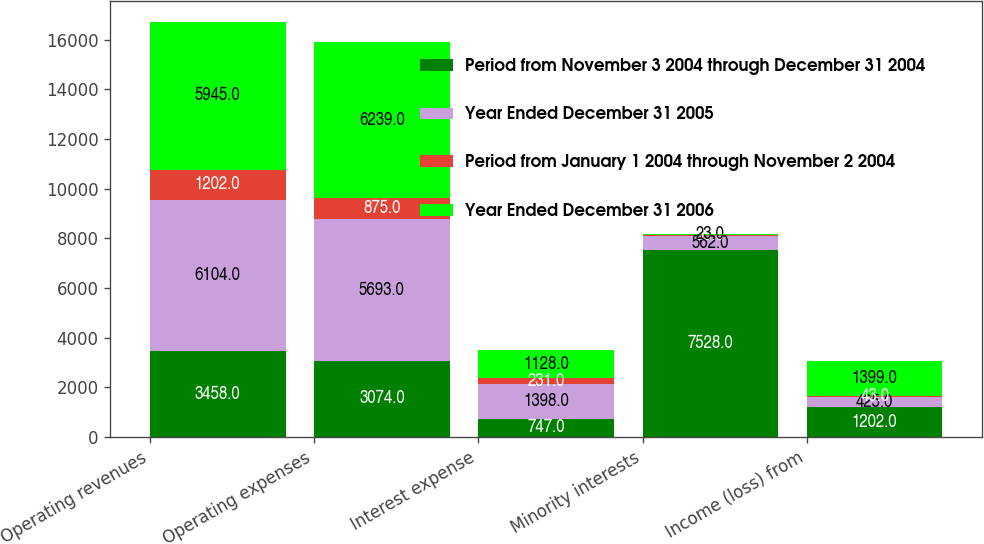Convert chart. <chart><loc_0><loc_0><loc_500><loc_500><stacked_bar_chart><ecel><fcel>Operating revenues<fcel>Operating expenses<fcel>Interest expense<fcel>Minority interests<fcel>Income (loss) from<nl><fcel>Period from November 3 2004 through December 31 2004<fcel>3458<fcel>3074<fcel>747<fcel>7528<fcel>1202<nl><fcel>Year Ended December 31 2005<fcel>6104<fcel>5693<fcel>1398<fcel>562<fcel>425<nl><fcel>Period from January 1 2004 through November 2 2004<fcel>1202<fcel>875<fcel>231<fcel>53<fcel>43<nl><fcel>Year Ended December 31 2006<fcel>5945<fcel>6239<fcel>1128<fcel>23<fcel>1399<nl></chart> 